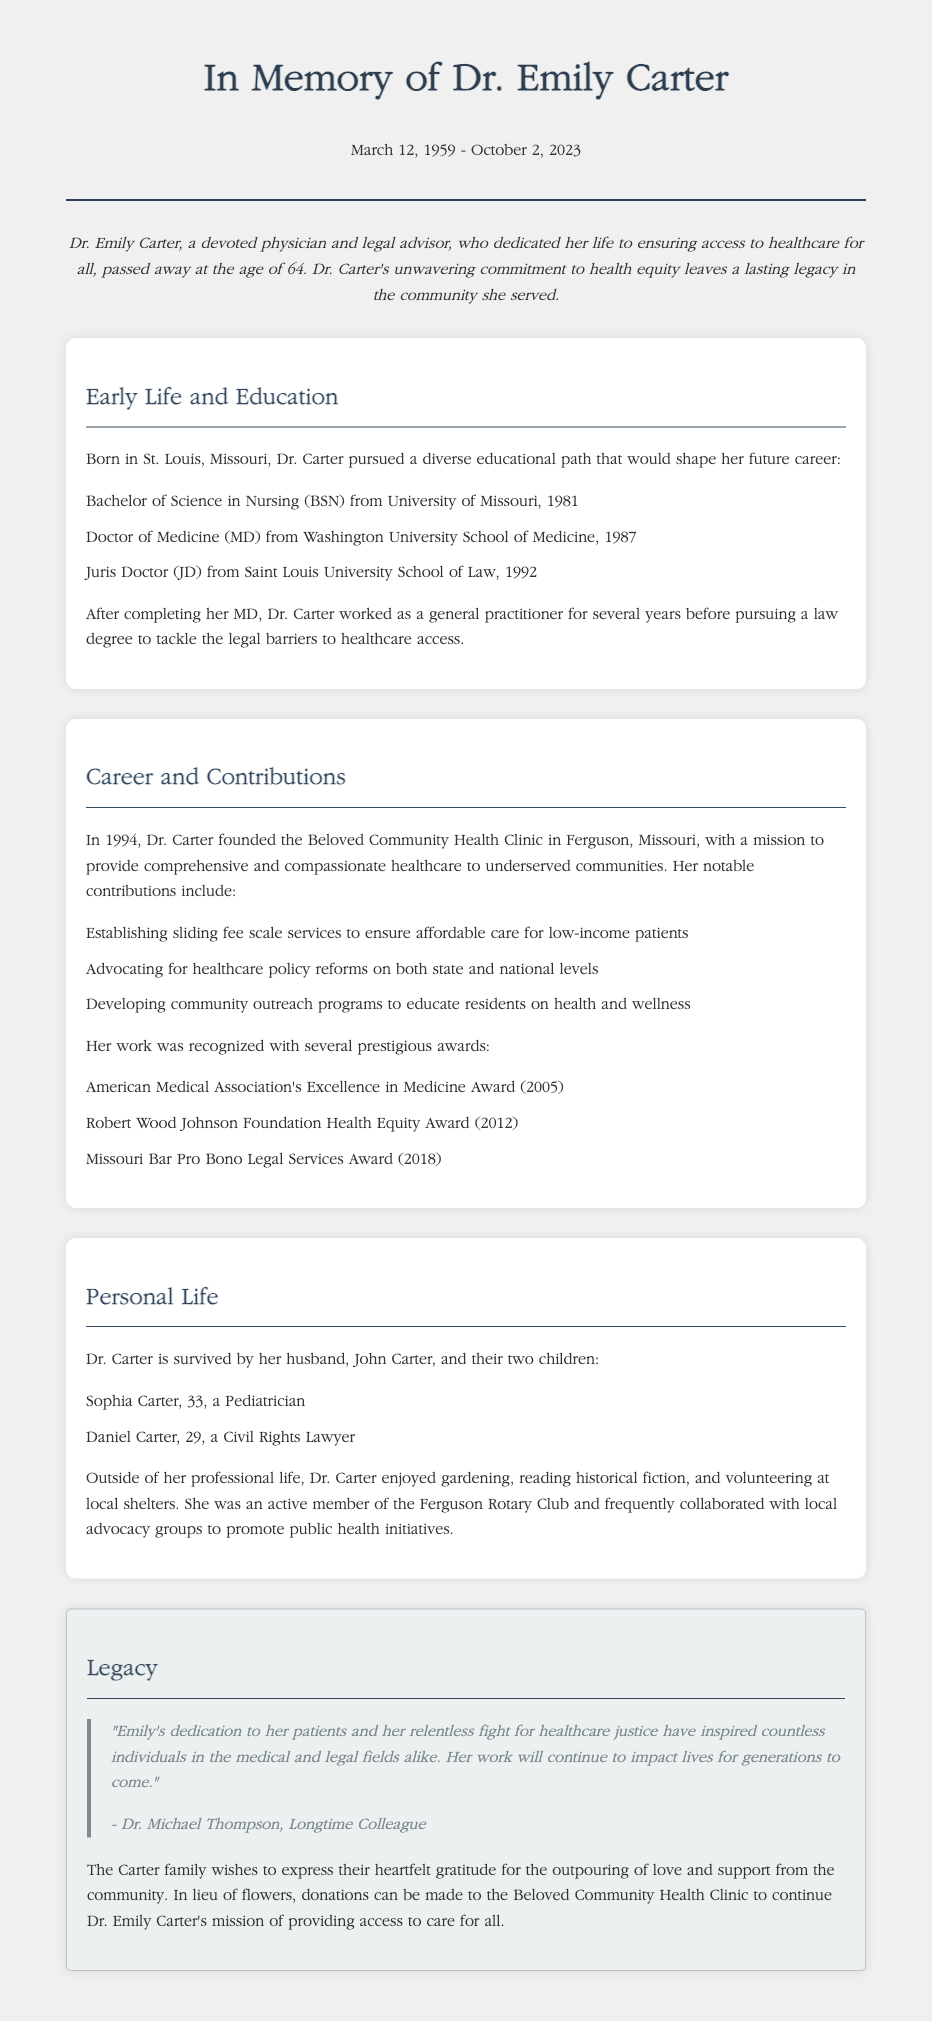What is the full name of the founder of the clinic? The document specifies the full name of the founder as Dr. Emily Carter.
Answer: Dr. Emily Carter What year was the Beloved Community Health Clinic founded? The text states that Dr. Carter founded the clinic in 1994.
Answer: 1994 What was Dr. Carter's profession before pursuing a law degree? The document mentions that Dr. Carter worked as a general practitioner after completing her MD.
Answer: General practitioner Which award did Dr. Carter receive in 2005? The document lists the American Medical Association's Excellence in Medicine Award as one of the awards she received in 2005.
Answer: American Medical Association's Excellence in Medicine Award How many children did Dr. Emily Carter have? The document states that Dr. Carter is survived by two children.
Answer: Two What was Dr. Carter's educational background? The document outlines her educational achievements, including a BSN, MD, and JD.
Answer: BSN, MD, JD What is a notable aspect of Dr. Carter's legacy? The quote from Dr. Michael Thompson highlights her dedication to healthcare justice and inspiration to others.
Answer: Healthcare justice What kind of services did the clinic offer? The document describes services provided by establishing sliding fee scales to help low-income patients.
Answer: Sliding fee scale services What hobby did Dr. Carter enjoy outside of her professional life? The document notes that Dr. Carter enjoyed gardening among her hobbies.
Answer: Gardening 